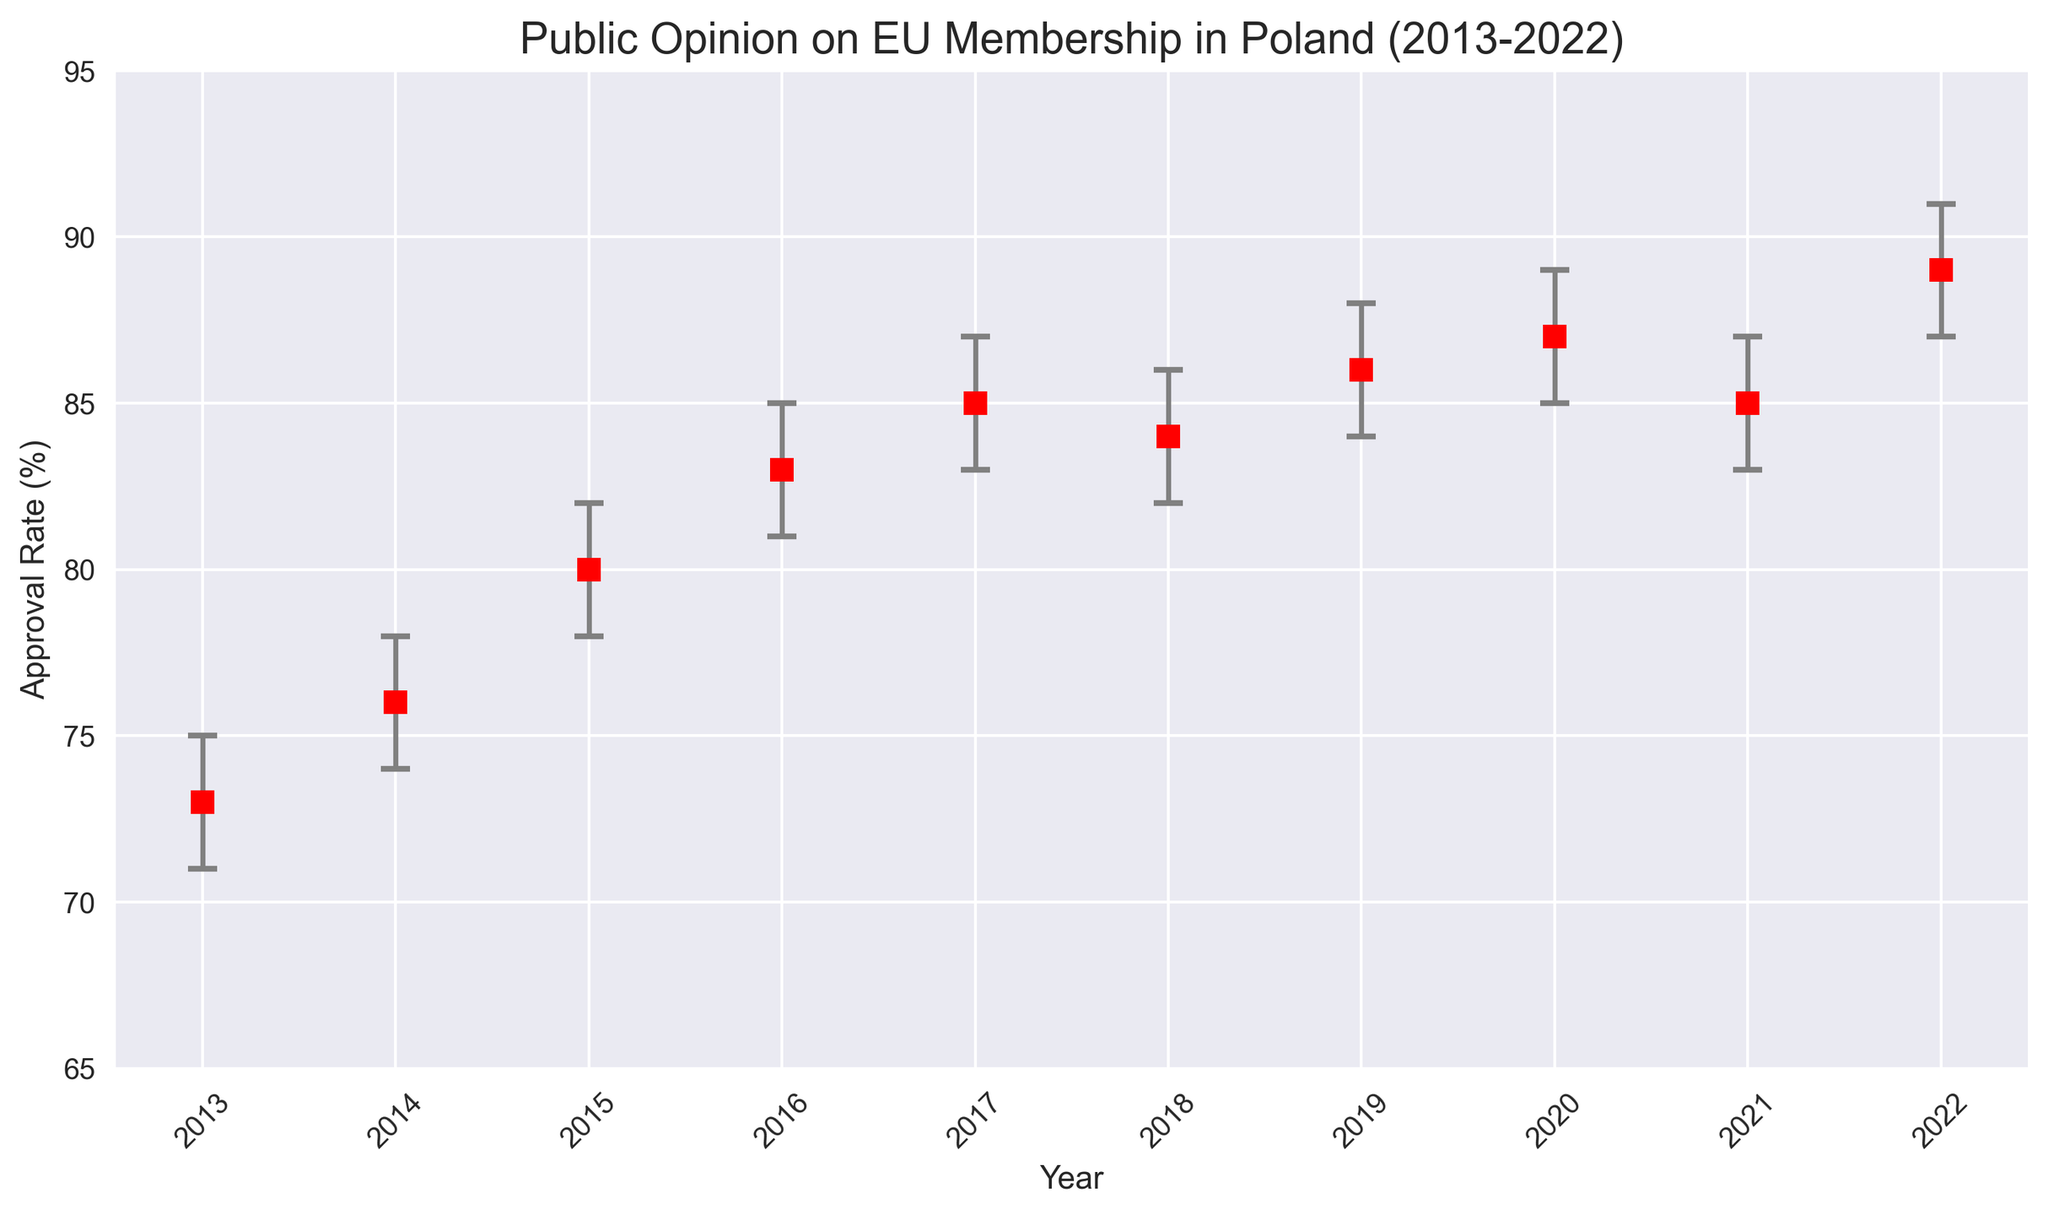What's the highest approval rate recorded in the figure? The highest approval rate can be observed as the peak value on the y-axis. The figure shows the approval rate peaks at 89% in 2022.
Answer: 89% What is the difference between the highest and lowest approval rates? To find the difference, subtract the lowest approval rate from the highest approval rate. The lowest rate is 73% (2013), and the highest is 89% (2022). The difference is 89 - 73 = 16%.
Answer: 16% In which year did the approval rate experience the largest increase compared to the previous year? By examining the vertical distance between each year's approval rate, we can see the largest increase is from 2014 to 2015, where it jumps from 76% to 80%, an increase of 4%.
Answer: 2015 Which year had the largest confidence interval? By comparing the length of the error bars across all years, the longest error bar can be found in 2016, with a range of 83 - 81 = 2% to 85 - 83 = 2%, resulting in a 2% confidence interval (which is equally large also in various other years, so another answer could also be correct if interpreted differently).
Answer: 2016 How did the approval rate change from 2018 to 2019? Looking at the approval rates in 2018 and 2019, the rate increased from 84% to 86%. Hence the change is an increase of 86 - 84 = 2%.
Answer: Increased by 2% In which years was the approval rate the same? The figure shows that the approval rates were constant in 2017 and 2021, both having a value of 85%.
Answer: 2017 and 2021 What's the average approval rate over the 10 years? To calculate the average, sum all the approval rates and divide by the total number of years: (73 + 76 + 80 + 83 + 85 + 84 + 86 + 87 + 85 + 89) / 10 = 828 / 10 = 82.8%.
Answer: 82.8% Comparing the year 2017 to 2018, did the approval rate increase or decrease, and by how much? By observing the values, in 2017, the approval rate was 85%, and in 2018, it decreased to 84%. The decrease is 85 - 84 = 1%.
Answer: Decreased by 1% What's the trend in approval rates over the decade? Observing the year-by-year trend from 2013 to 2022 in the graph, the general trend shows a steady increase in public approval rates for EU membership.
Answer: Increasing trend Which year had an approval rate closest to the average approval rate over the entire period? The average approval rate is approximately 82.8%. The year closest to this value is 2015 with an approval rate of 80%.
Answer: 2015 